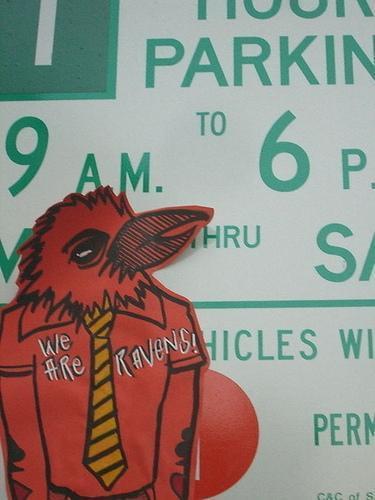How many cartoon birds are visible?
Give a very brief answer. 1. How many numbers are fully visible on the sign?
Give a very brief answer. 2. 